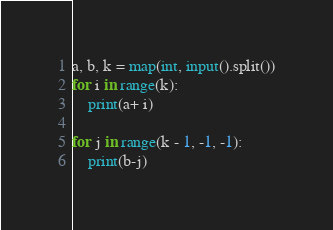Convert code to text. <code><loc_0><loc_0><loc_500><loc_500><_Python_>a, b, k = map(int, input().split())
for i in range(k):
    print(a+ i)

for j in range(k - 1, -1, -1):
    print(b-j)</code> 